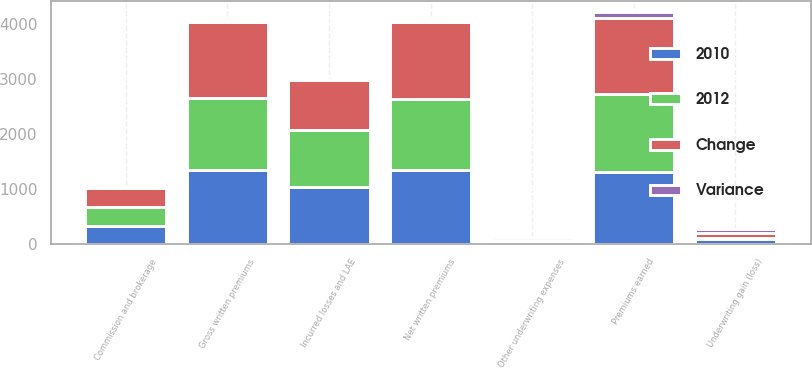Convert chart. <chart><loc_0><loc_0><loc_500><loc_500><stacked_bar_chart><ecel><fcel>Gross written premiums<fcel>Net written premiums<fcel>Premiums earned<fcel>Incurred losses and LAE<fcel>Commission and brokerage<fcel>Other underwriting expenses<fcel>Underwriting gain (loss)<nl><fcel>2012<fcel>1310.7<fcel>1306.5<fcel>1416.4<fcel>1050.4<fcel>350.6<fcel>44.8<fcel>29.4<nl><fcel>2010<fcel>1346.8<fcel>1344.3<fcel>1312.7<fcel>1034.1<fcel>327.8<fcel>39.3<fcel>88.5<nl><fcel>Change<fcel>1395.4<fcel>1392.6<fcel>1387<fcel>900.9<fcel>351.6<fcel>42.5<fcel>91.9<nl><fcel>Variance<fcel>36.1<fcel>37.8<fcel>103.7<fcel>16.3<fcel>22.8<fcel>5.5<fcel>59.1<nl></chart> 